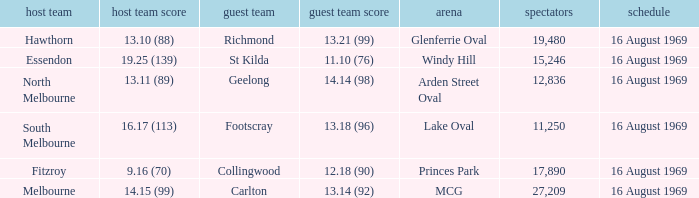Who was home at Princes Park? 9.16 (70). 